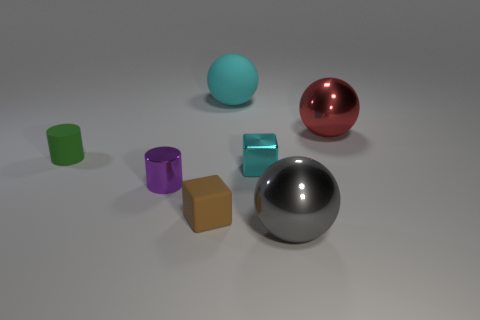Is the color of the big rubber thing the same as the tiny shiny block?
Make the answer very short. Yes. What color is the other thing that is the same shape as the small cyan object?
Provide a succinct answer. Brown. There is a cylinder that is left of the tiny purple cylinder; what is its size?
Offer a very short reply. Small. What shape is the matte thing that is in front of the large red sphere and behind the purple object?
Ensure brevity in your answer.  Cylinder. There is another metal thing that is the same shape as the brown object; what is its size?
Offer a very short reply. Small. What number of large gray balls have the same material as the purple cylinder?
Your response must be concise. 1. There is a small metallic block; is its color the same as the ball behind the red sphere?
Offer a very short reply. Yes. Are there more blue cylinders than big spheres?
Your response must be concise. No. The shiny block is what color?
Offer a terse response. Cyan. There is a big object on the left side of the cyan metallic block; is it the same color as the metal cube?
Make the answer very short. Yes. 